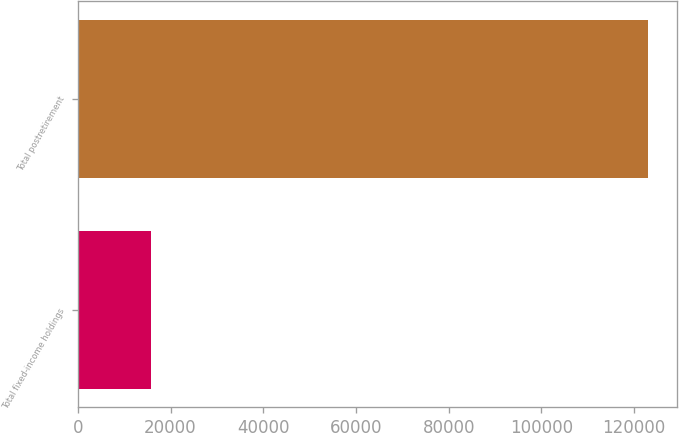<chart> <loc_0><loc_0><loc_500><loc_500><bar_chart><fcel>Total fixed-income holdings<fcel>Total postretirement<nl><fcel>15684<fcel>123106<nl></chart> 